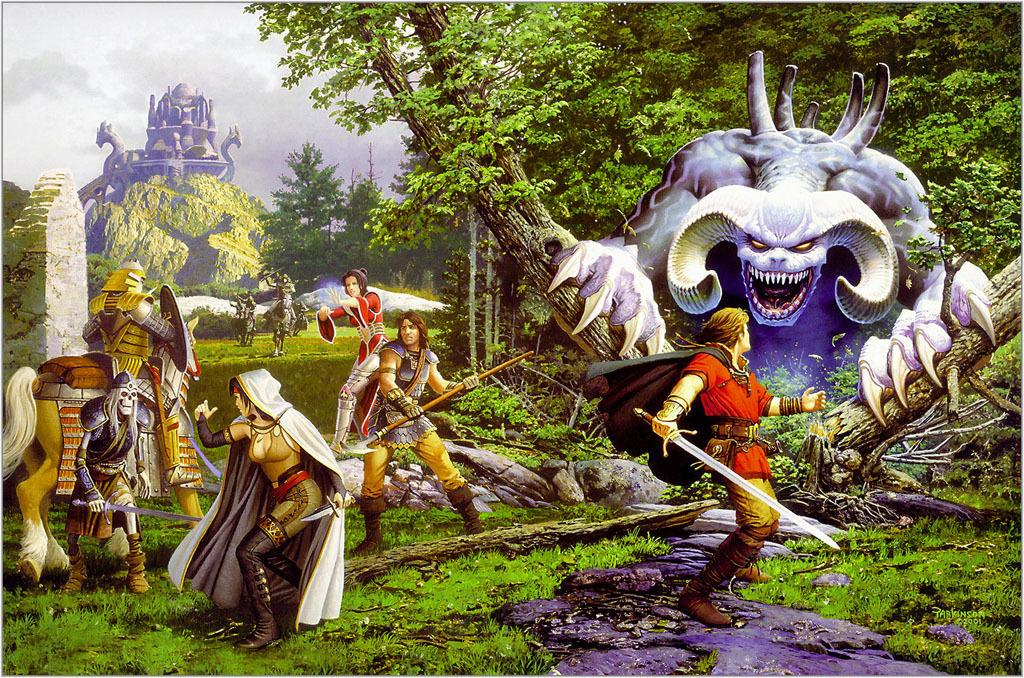What type of terrain is visible in the image? There is grass in the image. What are the people in the image doing? The people are fighting with monsters. What animals are present in the image? There are horses in the image. What weapons are being used in the image? There are swords in the image. What other natural elements can be seen in the image? There are trees and water in the image. What man-made structures are visible in the image? There are buildings in the image. What part of the natural environment is visible in the image? The sky is visible in the image. How many yokes are being used by the people in the image? There is no mention of yokes in the image; the people are fighting with swords. What type of account is being discussed by the people in the image? There is no mention of any accounts or discussions in the image; the people are fighting with monsters. 